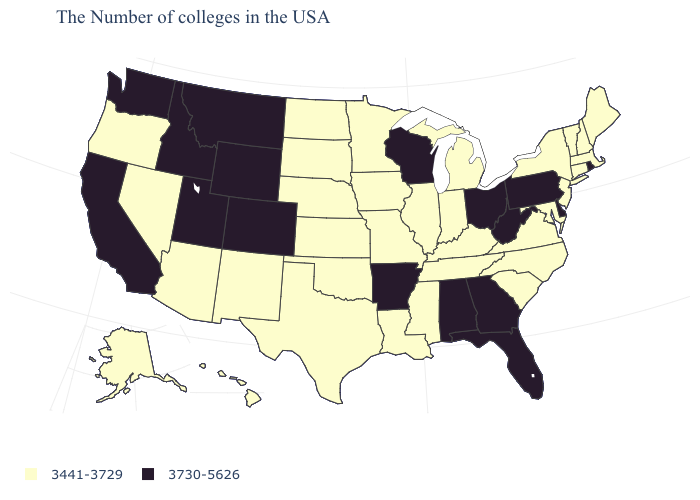Name the states that have a value in the range 3441-3729?
Give a very brief answer. Maine, Massachusetts, New Hampshire, Vermont, Connecticut, New York, New Jersey, Maryland, Virginia, North Carolina, South Carolina, Michigan, Kentucky, Indiana, Tennessee, Illinois, Mississippi, Louisiana, Missouri, Minnesota, Iowa, Kansas, Nebraska, Oklahoma, Texas, South Dakota, North Dakota, New Mexico, Arizona, Nevada, Oregon, Alaska, Hawaii. What is the value of Tennessee?
Short answer required. 3441-3729. Among the states that border West Virginia , does Kentucky have the lowest value?
Write a very short answer. Yes. Is the legend a continuous bar?
Write a very short answer. No. Does Washington have the same value as Hawaii?
Short answer required. No. Among the states that border Utah , does Arizona have the highest value?
Concise answer only. No. Which states have the lowest value in the Northeast?
Give a very brief answer. Maine, Massachusetts, New Hampshire, Vermont, Connecticut, New York, New Jersey. Is the legend a continuous bar?
Write a very short answer. No. Name the states that have a value in the range 3441-3729?
Be succinct. Maine, Massachusetts, New Hampshire, Vermont, Connecticut, New York, New Jersey, Maryland, Virginia, North Carolina, South Carolina, Michigan, Kentucky, Indiana, Tennessee, Illinois, Mississippi, Louisiana, Missouri, Minnesota, Iowa, Kansas, Nebraska, Oklahoma, Texas, South Dakota, North Dakota, New Mexico, Arizona, Nevada, Oregon, Alaska, Hawaii. Name the states that have a value in the range 3730-5626?
Write a very short answer. Rhode Island, Delaware, Pennsylvania, West Virginia, Ohio, Florida, Georgia, Alabama, Wisconsin, Arkansas, Wyoming, Colorado, Utah, Montana, Idaho, California, Washington. What is the value of Idaho?
Be succinct. 3730-5626. Name the states that have a value in the range 3441-3729?
Keep it brief. Maine, Massachusetts, New Hampshire, Vermont, Connecticut, New York, New Jersey, Maryland, Virginia, North Carolina, South Carolina, Michigan, Kentucky, Indiana, Tennessee, Illinois, Mississippi, Louisiana, Missouri, Minnesota, Iowa, Kansas, Nebraska, Oklahoma, Texas, South Dakota, North Dakota, New Mexico, Arizona, Nevada, Oregon, Alaska, Hawaii. Which states have the lowest value in the USA?
Short answer required. Maine, Massachusetts, New Hampshire, Vermont, Connecticut, New York, New Jersey, Maryland, Virginia, North Carolina, South Carolina, Michigan, Kentucky, Indiana, Tennessee, Illinois, Mississippi, Louisiana, Missouri, Minnesota, Iowa, Kansas, Nebraska, Oklahoma, Texas, South Dakota, North Dakota, New Mexico, Arizona, Nevada, Oregon, Alaska, Hawaii. Does Tennessee have the lowest value in the USA?
Be succinct. Yes. 